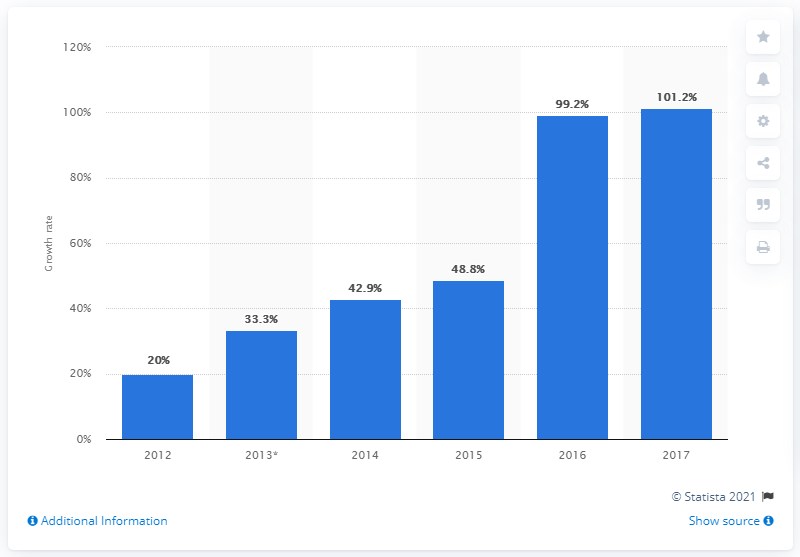Give some essential details in this illustration. The wearable mobile medical equipment market in China is expected to experience significant growth from 2015 to 2016, with an anticipated increase of 99.2%. 